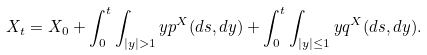<formula> <loc_0><loc_0><loc_500><loc_500>X _ { t } = X _ { 0 } + \int _ { 0 } ^ { t } \int _ { | y | > 1 } y p ^ { X } ( d s , d y ) + \int _ { 0 } ^ { t } \int _ { | y | \leq 1 } y q ^ { X } ( d s , d y ) .</formula> 